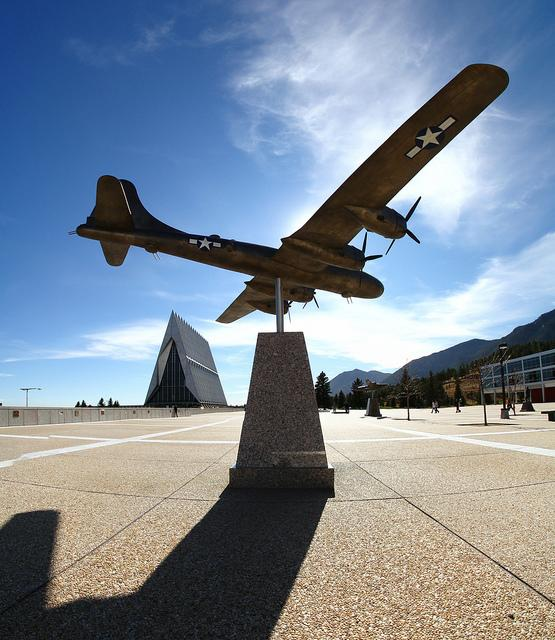How fast is this plane flying now? zero mph 